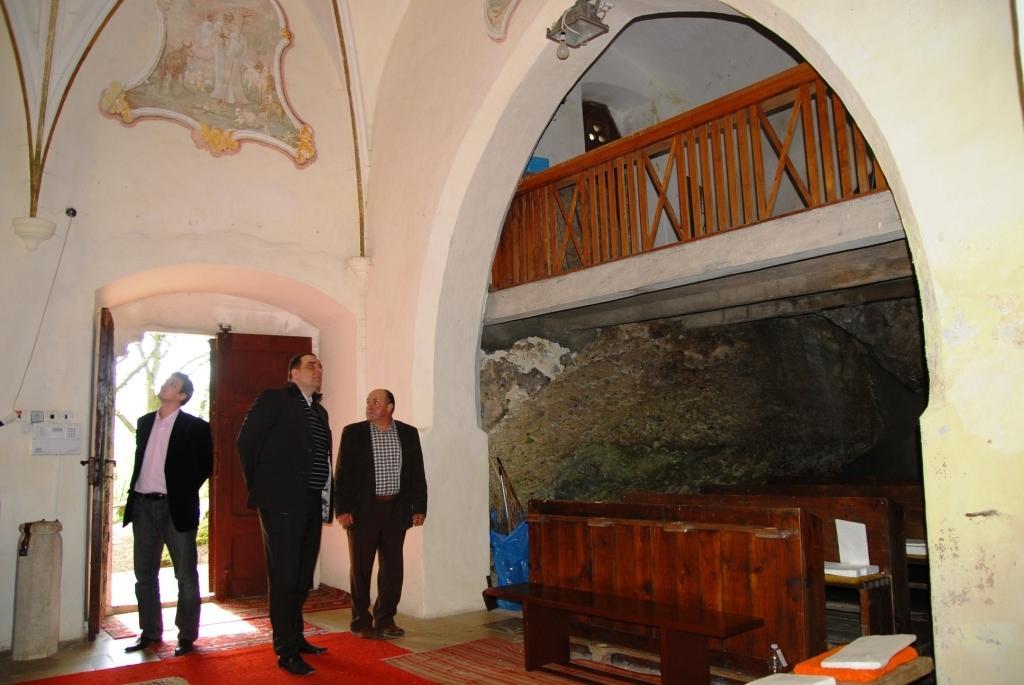In one or two sentences, can you explain what this image depicts? In the given image i can see a arch,fence,wooden object,people,door,floor mat and some other objects. 